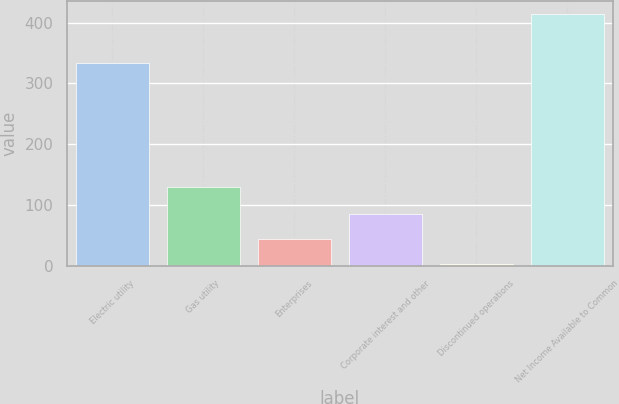<chart> <loc_0><loc_0><loc_500><loc_500><bar_chart><fcel>Electric utility<fcel>Gas utility<fcel>Enterprises<fcel>Corporate interest and other<fcel>Discontinued operations<fcel>Net Income Available to Common<nl><fcel>333<fcel>130<fcel>43.3<fcel>84.6<fcel>2<fcel>415<nl></chart> 